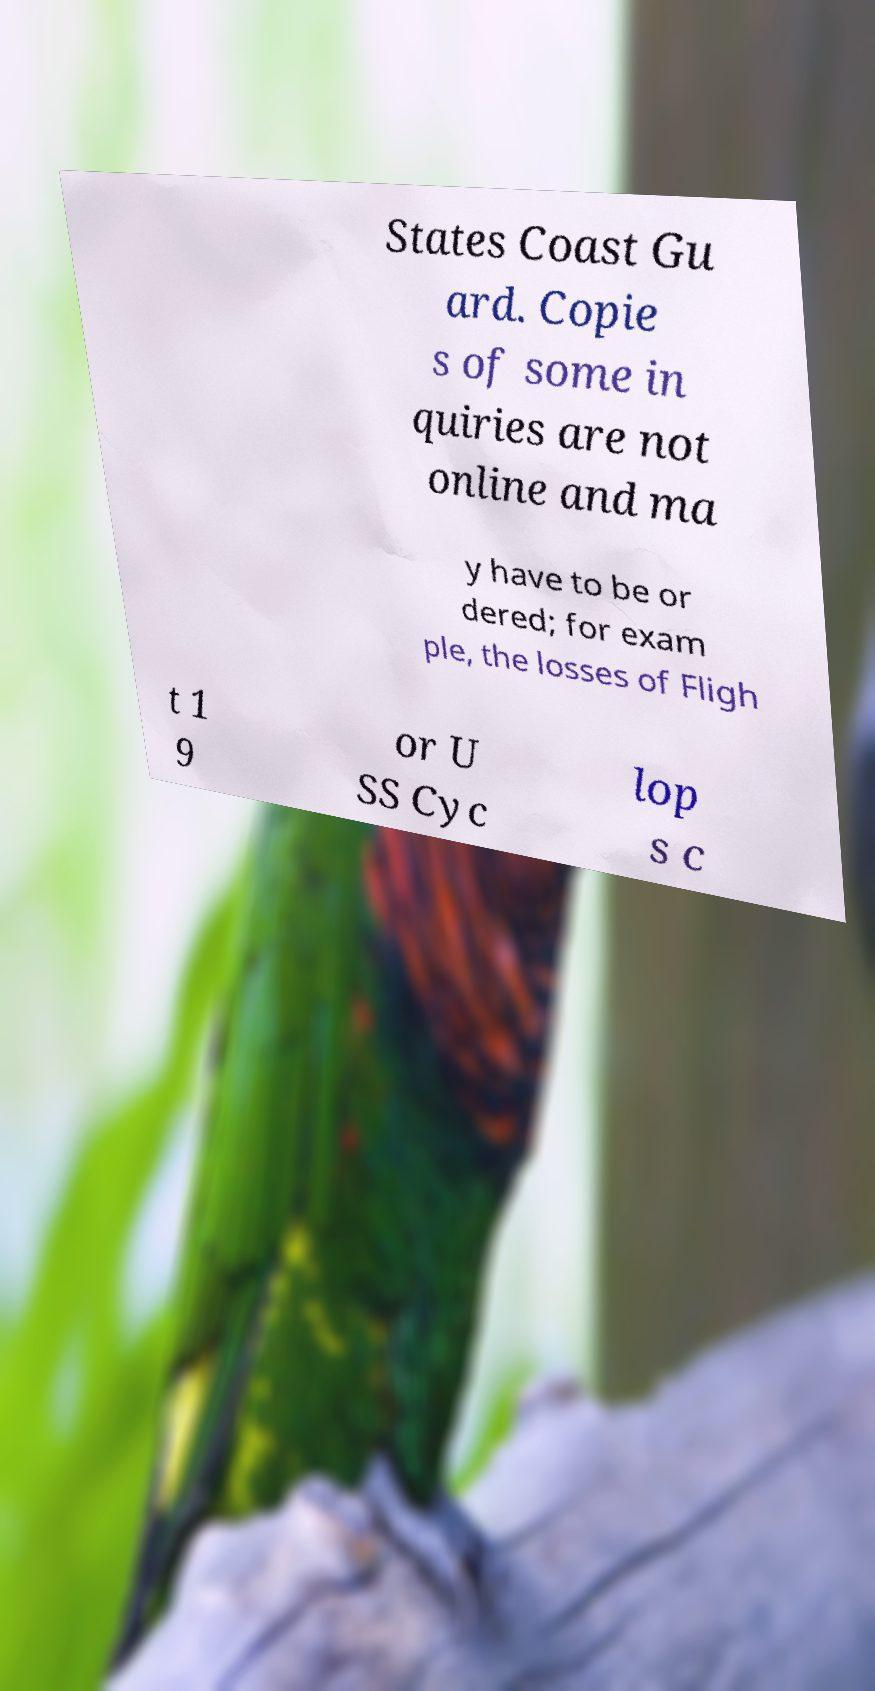Please read and relay the text visible in this image. What does it say? States Coast Gu ard. Copie s of some in quiries are not online and ma y have to be or dered; for exam ple, the losses of Fligh t 1 9 or U SS Cyc lop s c 